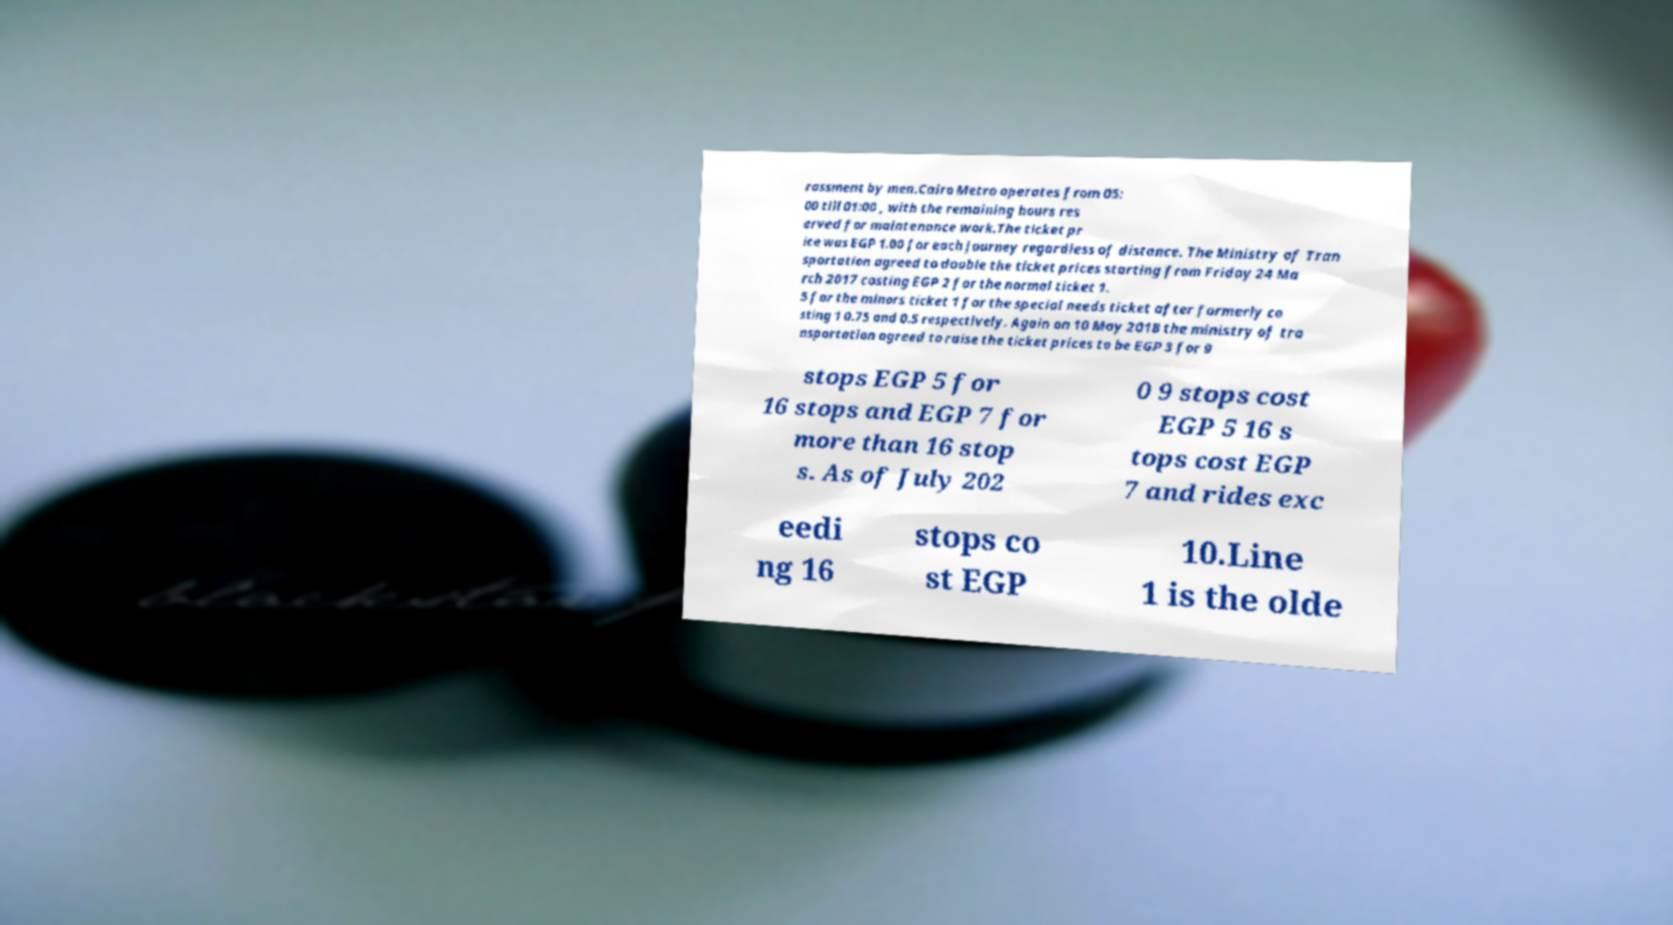Please read and relay the text visible in this image. What does it say? rassment by men.Cairo Metro operates from 05: 00 till 01:00 , with the remaining hours res erved for maintenance work.The ticket pr ice was EGP 1.00 for each journey regardless of distance. The Ministry of Tran sportation agreed to double the ticket prices starting from Friday 24 Ma rch 2017 costing EGP 2 for the normal ticket 1. 5 for the minors ticket 1 for the special needs ticket after formerly co sting 1 0.75 and 0.5 respectively. Again on 10 May 2018 the ministry of tra nsportation agreed to raise the ticket prices to be EGP 3 for 9 stops EGP 5 for 16 stops and EGP 7 for more than 16 stop s. As of July 202 0 9 stops cost EGP 5 16 s tops cost EGP 7 and rides exc eedi ng 16 stops co st EGP 10.Line 1 is the olde 